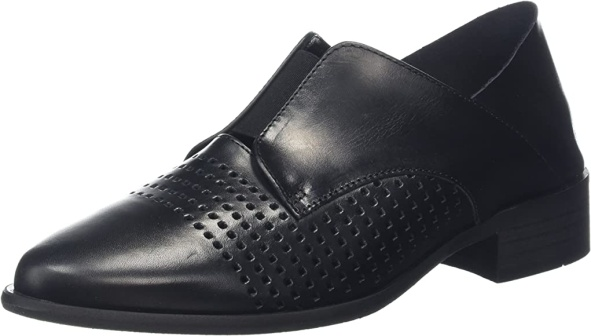Analyze the image in a comprehensive and detailed manner. The image features a single black leather shoe, viewed from a three-quarter perspective against a clean white background. The shoe boasts a pointed toe and is embellished with a diamond pattern of small perforations on the upper front section, adding a layer of sophistication and uniqueness. The light and shadow play accentuates the perforation details, making them stand out. The design is further enhanced by a sleek, triangular elastic panel on each side, contributing to the slip-on nature of the shoe for easy wear and providing a snug fit. The low, stacked heel with modest horizontal lines adds a refined touch to the overall design without being obtrusive. Despite its minimalistic design, the shoe emanates a sense of elegance and versatility, suitable for multiple occasions. The classic black color elevates its timeless appeal, ensuring it pairs well with a variety of outfits. The stark white background ensures that every detail of the shoe's design and craftsmanship is prominently highlighted. 